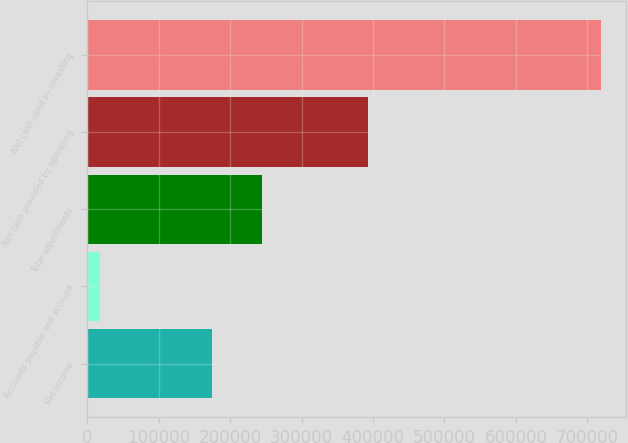Convert chart to OTSL. <chart><loc_0><loc_0><loc_500><loc_500><bar_chart><fcel>Net income<fcel>Accounts payable and accrued<fcel>Total adjustments<fcel>Net cash provided by operating<fcel>Net cash used by investing<nl><fcel>174197<fcel>18539<fcel>244191<fcel>393503<fcel>718482<nl></chart> 